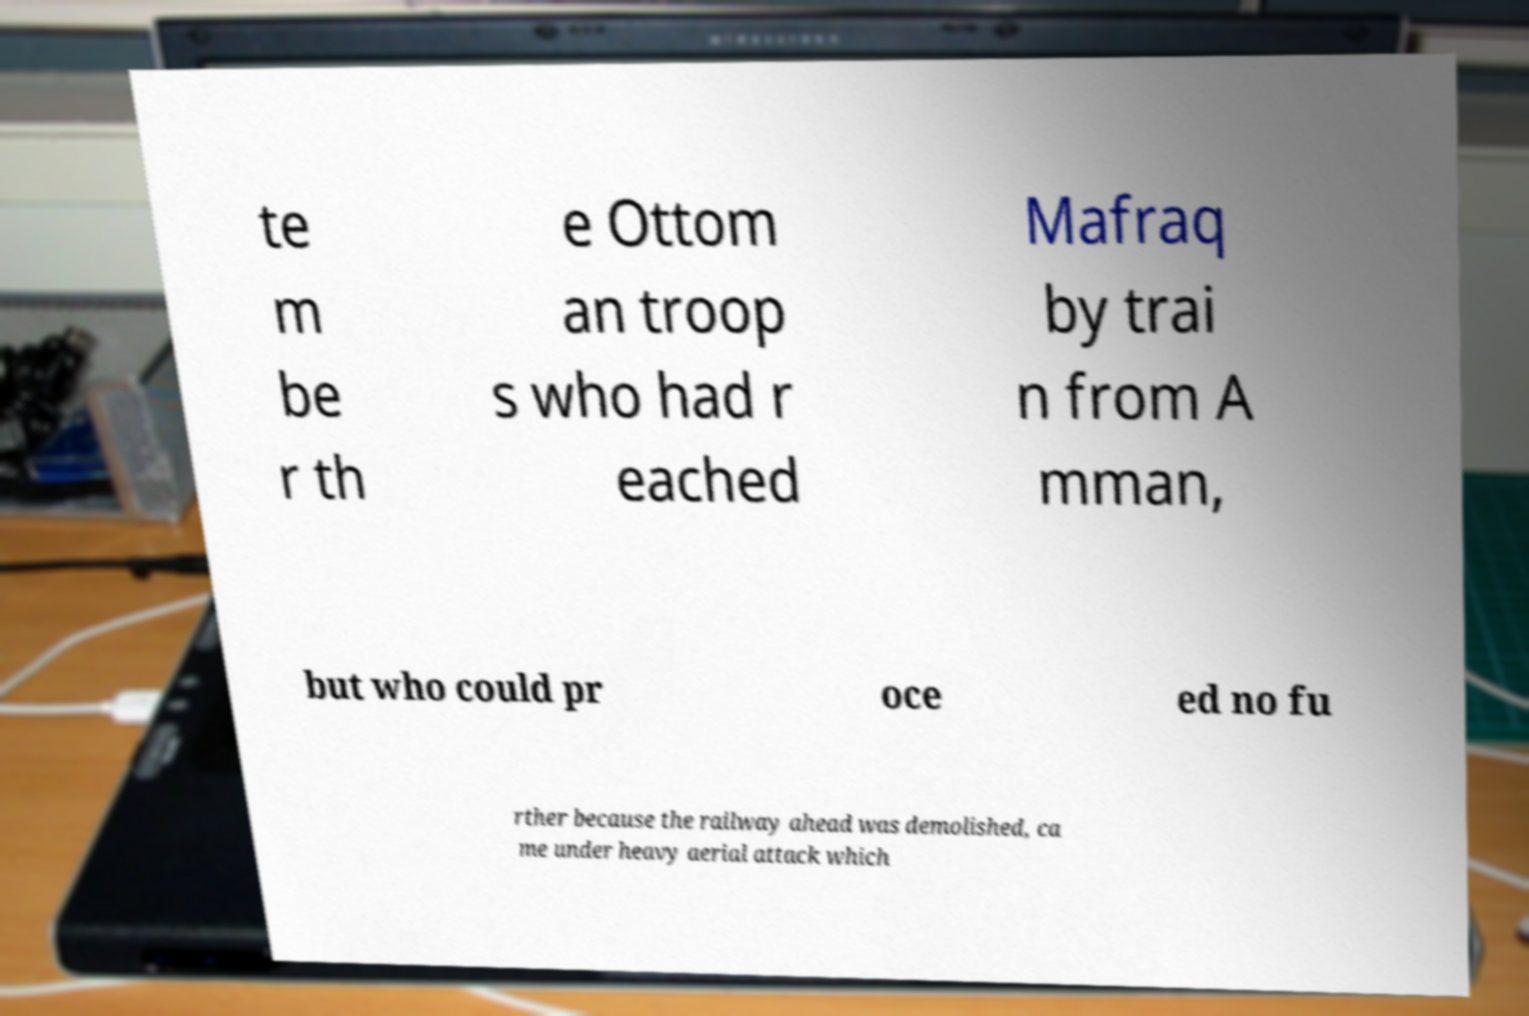Can you accurately transcribe the text from the provided image for me? te m be r th e Ottom an troop s who had r eached Mafraq by trai n from A mman, but who could pr oce ed no fu rther because the railway ahead was demolished, ca me under heavy aerial attack which 